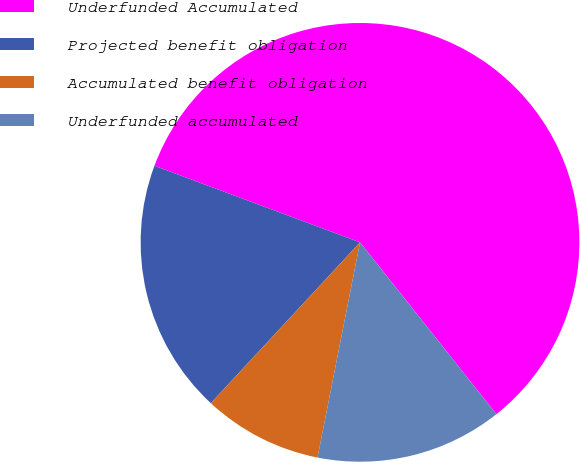<chart> <loc_0><loc_0><loc_500><loc_500><pie_chart><fcel>Underfunded Accumulated<fcel>Projected benefit obligation<fcel>Accumulated benefit obligation<fcel>Underfunded accumulated<nl><fcel>58.65%<fcel>18.77%<fcel>8.8%<fcel>13.78%<nl></chart> 